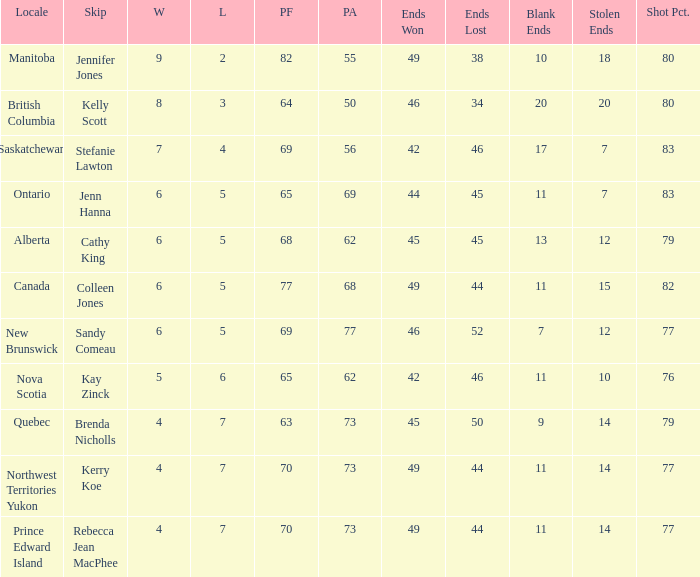What is the minimum PA when ends lost is 45? 62.0. 